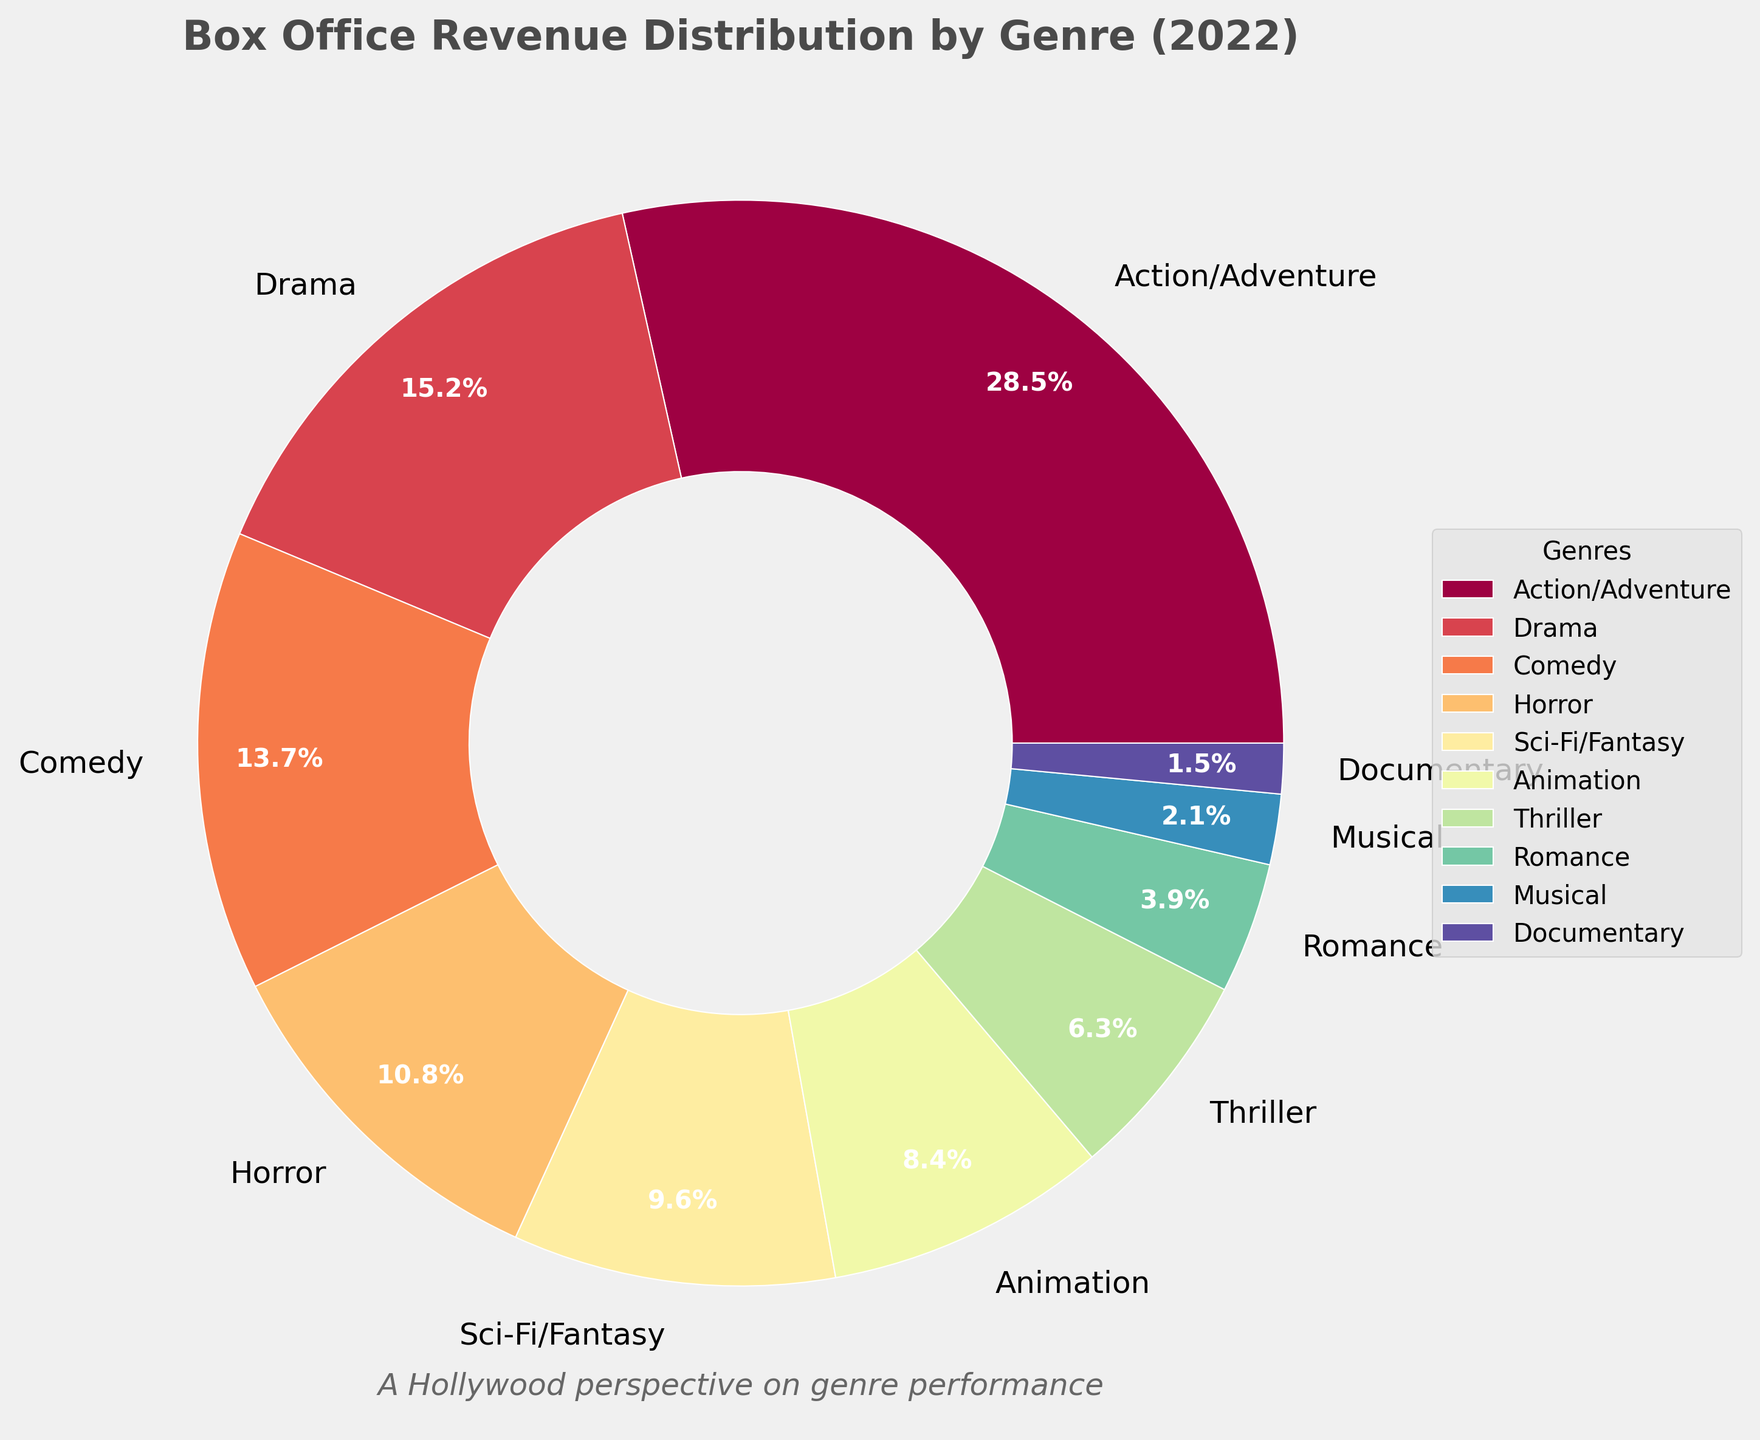What genre has the highest box office revenue percentage? By looking at the pie chart, the largest wedge corresponds to Action/Adventure. It is also listed at 28.5%, which is the highest percentage.
Answer: Action/Adventure What's the combined box office revenue percentage for Drama and Comedy? Locate the Drama and Comedy wedges. Drama has 15.2% and Comedy has 13.7%. Adding these together: 15.2 + 13.7 = 28.9%.
Answer: 28.9% Which genre has a smaller percentage of box office revenue, Sci-Fi/Fantasy or Horror? Find both genres in the chart. Sci-Fi/Fantasy is at 9.6% and Horror is at 10.8%. Comparing the two percentages, Sci-Fi/Fantasy is smaller.
Answer: Sci-Fi/Fantasy What is the difference in box office revenue percentage between Action/Adventure and Animation? Action/Adventure is at 28.5% and Animation is at 8.4%. Subtract the smaller percentage from the larger one: 28.5 - 8.4 = 20.1%.
Answer: 20.1% What is the color of the Drama wedge in the pie chart? Identify the wedge representing Drama. By examining its position and color in the chart, it can be described as being close to red or reddish.
Answer: Red (or reddish) What's the sum of the box office revenue percentages for all genres except the top three genres? The top three genres are Action/Adventure (28.5%), Drama (15.2%), and Comedy (13.7%). Sum of these is 28.5 + 15.2 + 13.7 = 57.4%. Subtract this from 100% (total percentage): 100 - 57.4 = 42.6%.
Answer: 42.6% Is the box office revenue percentage for Romance higher or lower than Thriller? Locate Thriller and Romance in the chart. Thriller is at 6.3% and Romance is at 3.9%. Comparing the two, Romance is lower.
Answer: Lower Which genres have their wedges closely grouped together in the chart's legend? Look at the legend closely. Genres like Romance, Musical, and Documentary appear quite close in the legend due to their smaller percentages.
Answer: Romance, Musical, Documentary 